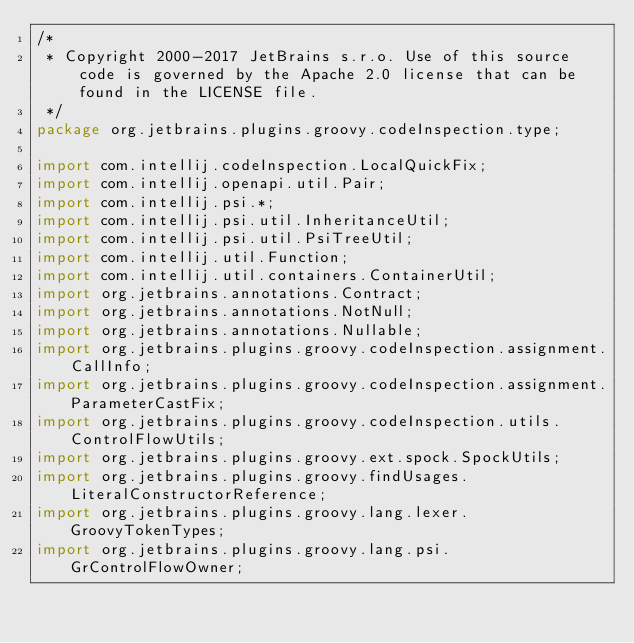<code> <loc_0><loc_0><loc_500><loc_500><_Java_>/*
 * Copyright 2000-2017 JetBrains s.r.o. Use of this source code is governed by the Apache 2.0 license that can be found in the LICENSE file.
 */
package org.jetbrains.plugins.groovy.codeInspection.type;

import com.intellij.codeInspection.LocalQuickFix;
import com.intellij.openapi.util.Pair;
import com.intellij.psi.*;
import com.intellij.psi.util.InheritanceUtil;
import com.intellij.psi.util.PsiTreeUtil;
import com.intellij.util.Function;
import com.intellij.util.containers.ContainerUtil;
import org.jetbrains.annotations.Contract;
import org.jetbrains.annotations.NotNull;
import org.jetbrains.annotations.Nullable;
import org.jetbrains.plugins.groovy.codeInspection.assignment.CallInfo;
import org.jetbrains.plugins.groovy.codeInspection.assignment.ParameterCastFix;
import org.jetbrains.plugins.groovy.codeInspection.utils.ControlFlowUtils;
import org.jetbrains.plugins.groovy.ext.spock.SpockUtils;
import org.jetbrains.plugins.groovy.findUsages.LiteralConstructorReference;
import org.jetbrains.plugins.groovy.lang.lexer.GroovyTokenTypes;
import org.jetbrains.plugins.groovy.lang.psi.GrControlFlowOwner;</code> 